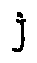Convert formula to latex. <formula><loc_0><loc_0><loc_500><loc_500>j</formula> 